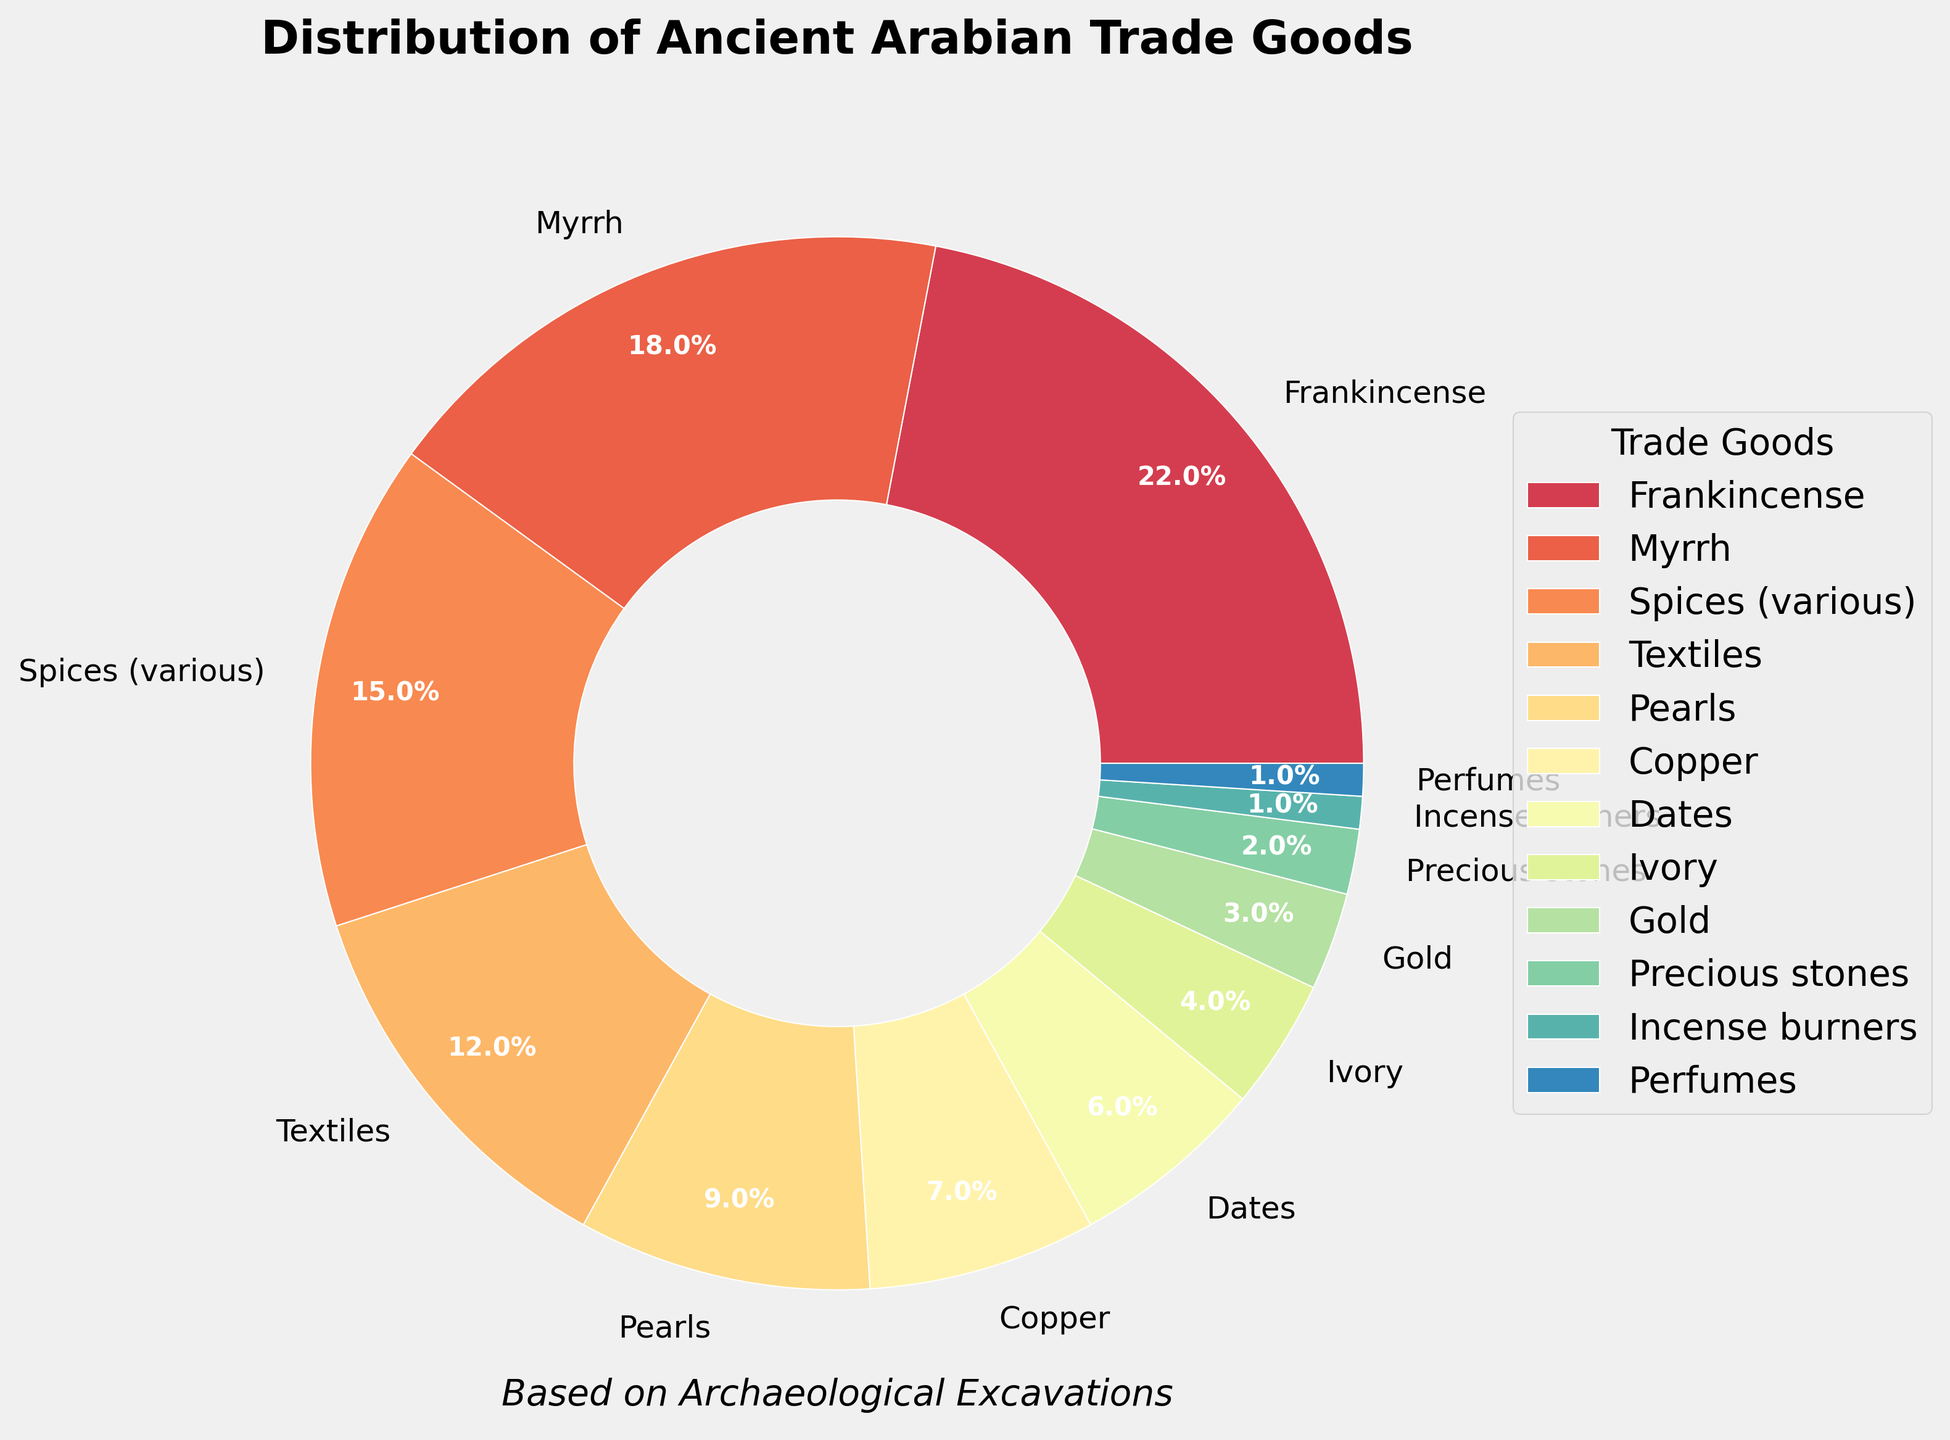Which trade good has the highest percentage in the pie chart? The trade good with the highest percentage can be identified by looking at the labeled wedges in the pie chart. The "Frankincense" wedge has the largest size and is labeled with "22%", which is the highest percentage shown.
Answer: Frankincense What is the combined percentage of Textiles, Pearls, and Copper? To find the combined percentage, we add the percentages of Textiles (12%), Pearls (9%), and Copper (7%). So, 12% + 9% + 7% = 28%.
Answer: 28% Which trade goods together make up less than 5% of the total? We need to look at the wedges representing trade goods with percentages less than 5%. These are Ivory (4%), Gold (3%), Precious stones (2%), Incense burners (1%), and Perfumes (1%).
Answer: Ivory, Gold, Precious stones, Incense burners, Perfumes How does the percentage of Myrrh compare to the percentage of Spices (various)? To compare, check the percentage labels for both trade goods in the pie chart. Myrrh is at 18%, while Spices (various) are at 15%. So, Myrrh has a higher percentage than Spices.
Answer: Myrrh has a higher percentage What's the total percentage of goods with individual values of 10% or more? We should sum up the percentages for trade goods with individual values of 10% or more. Frankincense (22%), Myrrh (18%), Spices (15%), and Textiles (12%) meet this criterion. So, 22% + 18% + 15% + 12% = 67%.
Answer: 67% Which trade good has the smallest wedge, and what is its percentage? The smallest wedge will have the least percentage value in the pie. Both Incense burners and Perfumes have the smallest size and are labeled with 1%.
Answer: Incense burners, Perfumes (tied at 1%) If Copper and Dates were combined into a single category, what would be their combined percentage? To find the combined percentage, we add the percentages of Copper (7%) and Dates (6%). So, 7% + 6% = 13%.
Answer: 13% Are there more goods whose individual percentages are less than 10% or more than 10%? We count the goods with percentages less than 10% (Pearls, Copper, Dates, Ivory, Gold, Precious stones, Incense burners, Perfumes) and those with percentages more than 10% (Frankincense, Myrrh, Spices, Textiles). There are 8 goods with less than 10% and 4 goods with more than 10%.
Answer: More goods with less than 10% What is the average percentage of the top three most common trade goods? First, we identify the top three most common trade goods: Frankincense (22%), Myrrh (18%), and Spices (15%). The average percentage is calculated as (22% + 18% + 15%) / 3 = 55% / 3 = 18.33%.
Answer: 18.33% Compare the combined percentage of trade goods related to aromatics (Frankincense, Myrrh, and Perfumes) to those related to jewelry (Pearls, Precious stones, and Gold). Which category is higher? To find the combined percentages, we add the aromatic goods: Frankincense (22%), Myrrh (18%), and Perfumes (1%) for a total of 41%. For jewelry: Pearls (9%), Precious stones (2%), and Gold (3%) for a total of 14%. Aromatics are higher at 41%.
Answer: Aromatics (41%) 